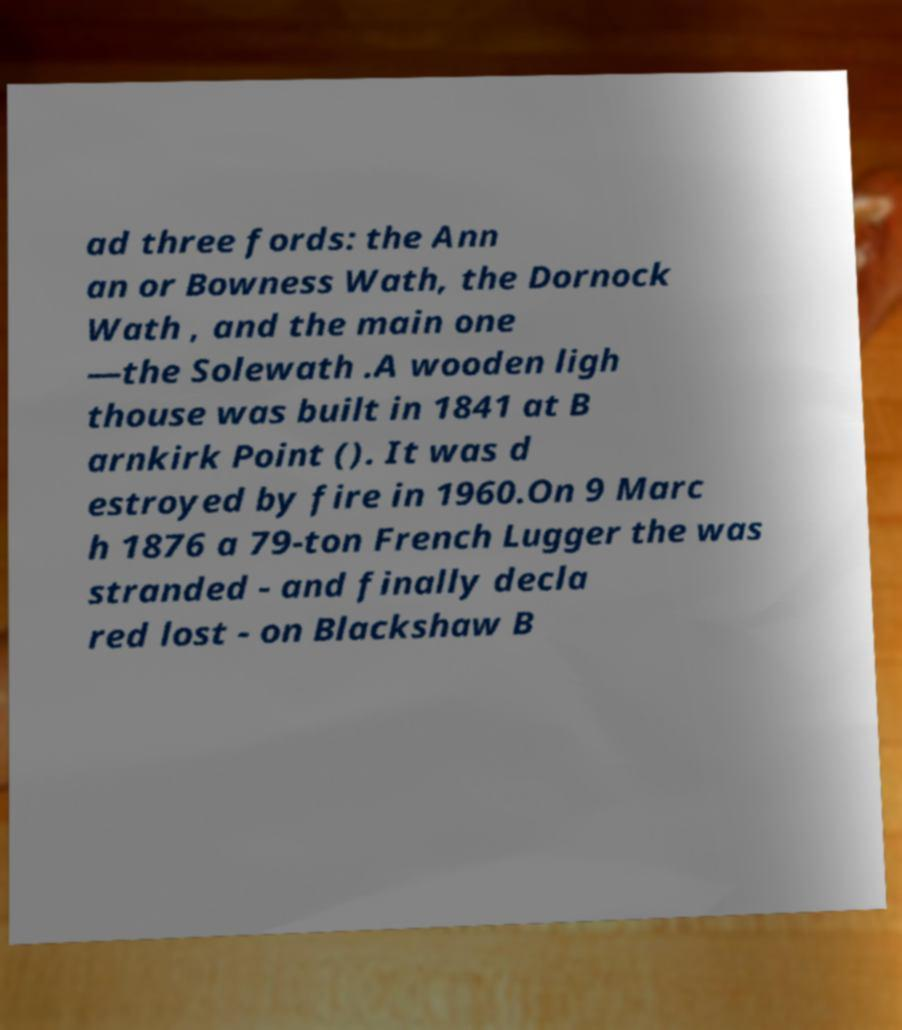There's text embedded in this image that I need extracted. Can you transcribe it verbatim? ad three fords: the Ann an or Bowness Wath, the Dornock Wath , and the main one —the Solewath .A wooden ligh thouse was built in 1841 at B arnkirk Point (). It was d estroyed by fire in 1960.On 9 Marc h 1876 a 79-ton French Lugger the was stranded - and finally decla red lost - on Blackshaw B 